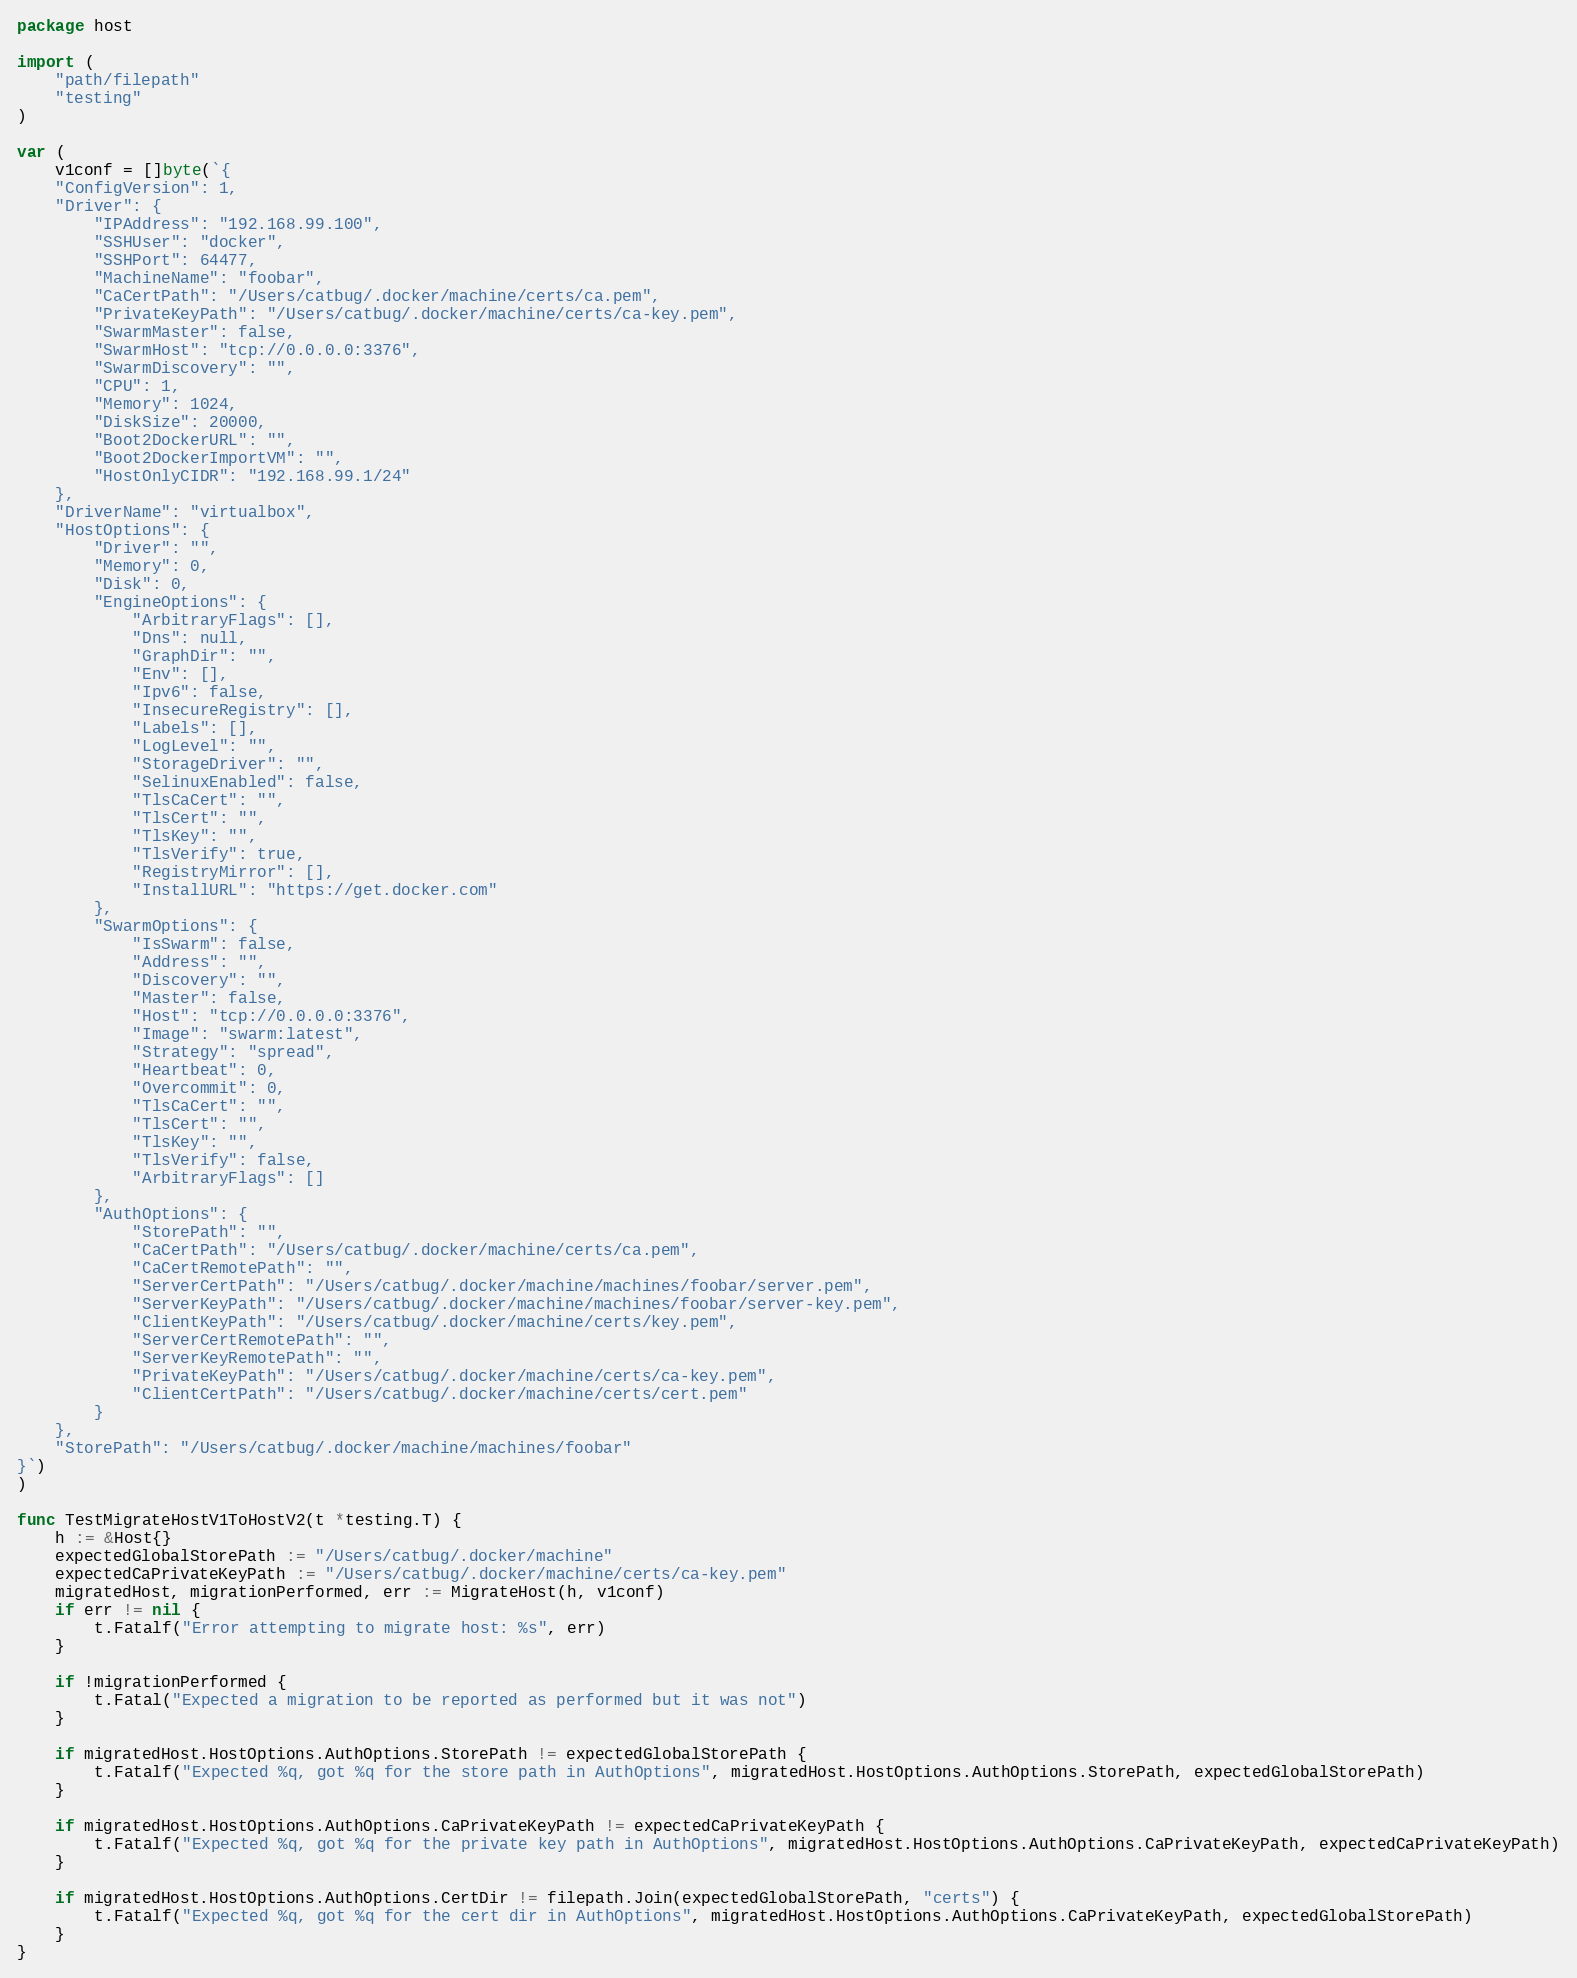Convert code to text. <code><loc_0><loc_0><loc_500><loc_500><_Go_>package host

import (
	"path/filepath"
	"testing"
)

var (
	v1conf = []byte(`{
    "ConfigVersion": 1,
    "Driver": {
        "IPAddress": "192.168.99.100",
        "SSHUser": "docker",
        "SSHPort": 64477,
        "MachineName": "foobar",
        "CaCertPath": "/Users/catbug/.docker/machine/certs/ca.pem",
        "PrivateKeyPath": "/Users/catbug/.docker/machine/certs/ca-key.pem",
        "SwarmMaster": false,
        "SwarmHost": "tcp://0.0.0.0:3376",
        "SwarmDiscovery": "",
        "CPU": 1,
        "Memory": 1024,
        "DiskSize": 20000,
        "Boot2DockerURL": "",
        "Boot2DockerImportVM": "",
        "HostOnlyCIDR": "192.168.99.1/24"
    },
    "DriverName": "virtualbox",
    "HostOptions": {
        "Driver": "",
        "Memory": 0,
        "Disk": 0,
        "EngineOptions": {
            "ArbitraryFlags": [],
            "Dns": null,
            "GraphDir": "",
            "Env": [],
            "Ipv6": false,
            "InsecureRegistry": [],
            "Labels": [],
            "LogLevel": "",
            "StorageDriver": "",
            "SelinuxEnabled": false,
            "TlsCaCert": "",
            "TlsCert": "",
            "TlsKey": "",
            "TlsVerify": true,
            "RegistryMirror": [],
            "InstallURL": "https://get.docker.com"
        },
        "SwarmOptions": {
            "IsSwarm": false,
            "Address": "",
            "Discovery": "",
            "Master": false,
            "Host": "tcp://0.0.0.0:3376",
            "Image": "swarm:latest",
            "Strategy": "spread",
            "Heartbeat": 0,
            "Overcommit": 0,
            "TlsCaCert": "",
            "TlsCert": "",
            "TlsKey": "",
            "TlsVerify": false,
            "ArbitraryFlags": []
        },
        "AuthOptions": {
            "StorePath": "",
            "CaCertPath": "/Users/catbug/.docker/machine/certs/ca.pem",
            "CaCertRemotePath": "",
            "ServerCertPath": "/Users/catbug/.docker/machine/machines/foobar/server.pem",
            "ServerKeyPath": "/Users/catbug/.docker/machine/machines/foobar/server-key.pem",
            "ClientKeyPath": "/Users/catbug/.docker/machine/certs/key.pem",
            "ServerCertRemotePath": "",
            "ServerKeyRemotePath": "",
            "PrivateKeyPath": "/Users/catbug/.docker/machine/certs/ca-key.pem",
            "ClientCertPath": "/Users/catbug/.docker/machine/certs/cert.pem"
        }
    },
    "StorePath": "/Users/catbug/.docker/machine/machines/foobar"
}`)
)

func TestMigrateHostV1ToHostV2(t *testing.T) {
	h := &Host{}
	expectedGlobalStorePath := "/Users/catbug/.docker/machine"
	expectedCaPrivateKeyPath := "/Users/catbug/.docker/machine/certs/ca-key.pem"
	migratedHost, migrationPerformed, err := MigrateHost(h, v1conf)
	if err != nil {
		t.Fatalf("Error attempting to migrate host: %s", err)
	}

	if !migrationPerformed {
		t.Fatal("Expected a migration to be reported as performed but it was not")
	}

	if migratedHost.HostOptions.AuthOptions.StorePath != expectedGlobalStorePath {
		t.Fatalf("Expected %q, got %q for the store path in AuthOptions", migratedHost.HostOptions.AuthOptions.StorePath, expectedGlobalStorePath)
	}

	if migratedHost.HostOptions.AuthOptions.CaPrivateKeyPath != expectedCaPrivateKeyPath {
		t.Fatalf("Expected %q, got %q for the private key path in AuthOptions", migratedHost.HostOptions.AuthOptions.CaPrivateKeyPath, expectedCaPrivateKeyPath)
	}

	if migratedHost.HostOptions.AuthOptions.CertDir != filepath.Join(expectedGlobalStorePath, "certs") {
		t.Fatalf("Expected %q, got %q for the cert dir in AuthOptions", migratedHost.HostOptions.AuthOptions.CaPrivateKeyPath, expectedGlobalStorePath)
	}
}
</code> 